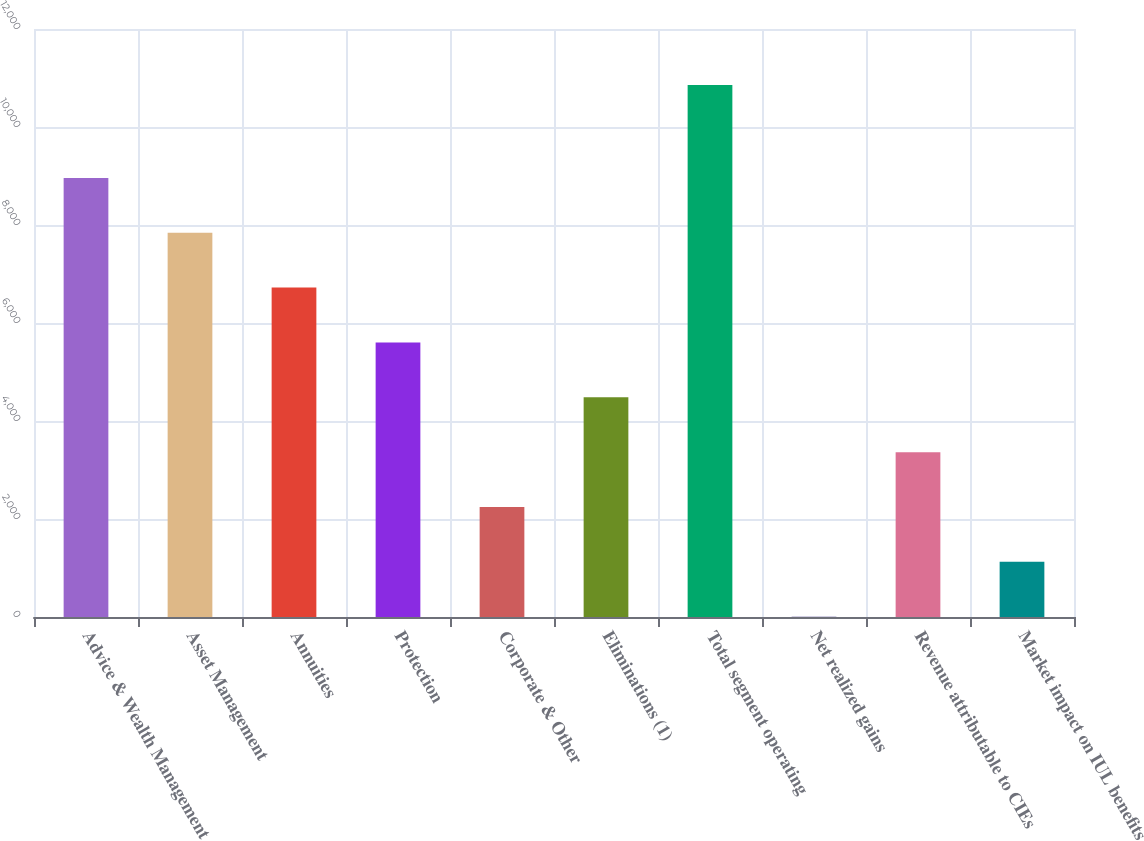Convert chart. <chart><loc_0><loc_0><loc_500><loc_500><bar_chart><fcel>Advice & Wealth Management<fcel>Asset Management<fcel>Annuities<fcel>Protection<fcel>Corporate & Other<fcel>Eliminations (1)<fcel>Total segment operating<fcel>Net realized gains<fcel>Revenue attributable to CIEs<fcel>Market impact on IUL benefits<nl><fcel>8960.6<fcel>7841.4<fcel>6722.2<fcel>5603<fcel>2245.4<fcel>4483.8<fcel>10857<fcel>7<fcel>3364.6<fcel>1126.2<nl></chart> 